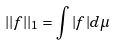<formula> <loc_0><loc_0><loc_500><loc_500>| | f | | _ { 1 } = \int | f | d \mu</formula> 